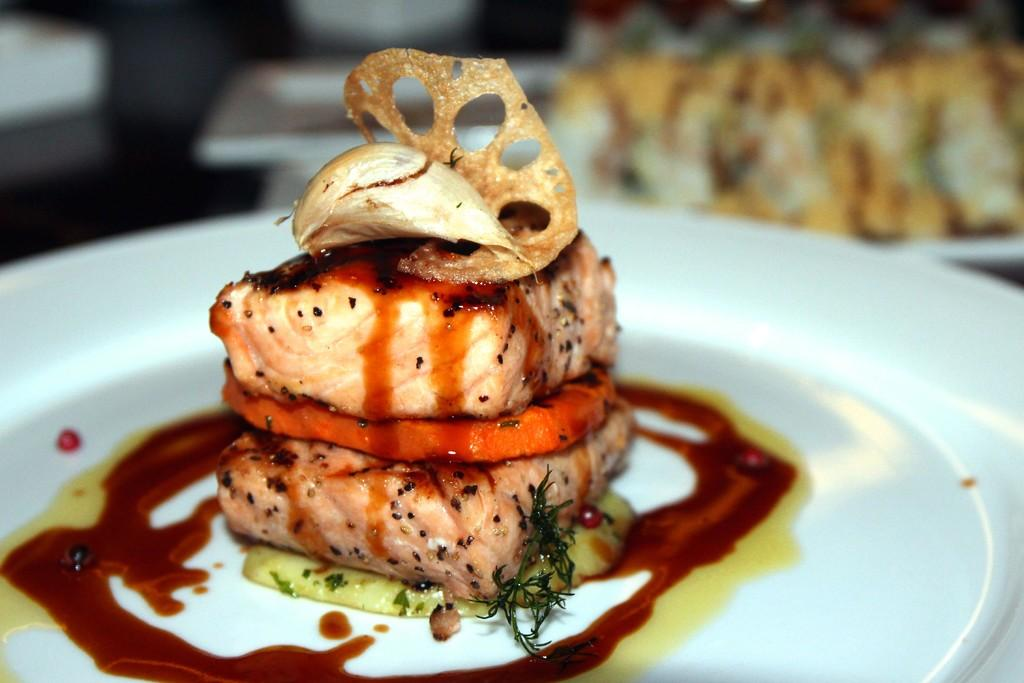What type of cooked food can be seen in the image? There is a cooked food item in the image. How is the food item presented? The food item is served with sauces. What color is the plate on which the food is served? The plate is white. Can you describe the background of the plate? The background of the plate is blurred. What type of waste is visible in the image? There is no waste visible in the image; it only features a cooked food item served with sauces on a white plate with a blurred background. 